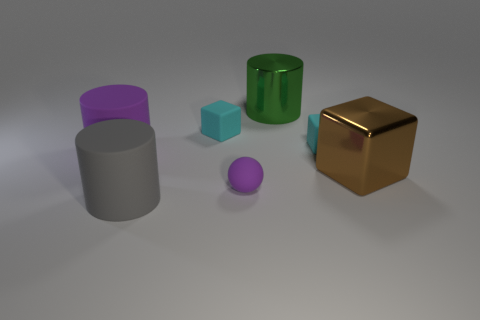Subtract all cyan cubes. How many cubes are left? 1 Subtract all brown cubes. How many cubes are left? 2 Subtract 1 cubes. How many cubes are left? 2 Subtract all spheres. How many objects are left? 6 Subtract all red cubes. How many gray cylinders are left? 1 Add 1 brown shiny cubes. How many objects exist? 8 Subtract 0 blue cubes. How many objects are left? 7 Subtract all blue spheres. Subtract all red cylinders. How many spheres are left? 1 Subtract all tiny cyan blocks. Subtract all rubber blocks. How many objects are left? 3 Add 1 tiny rubber blocks. How many tiny rubber blocks are left? 3 